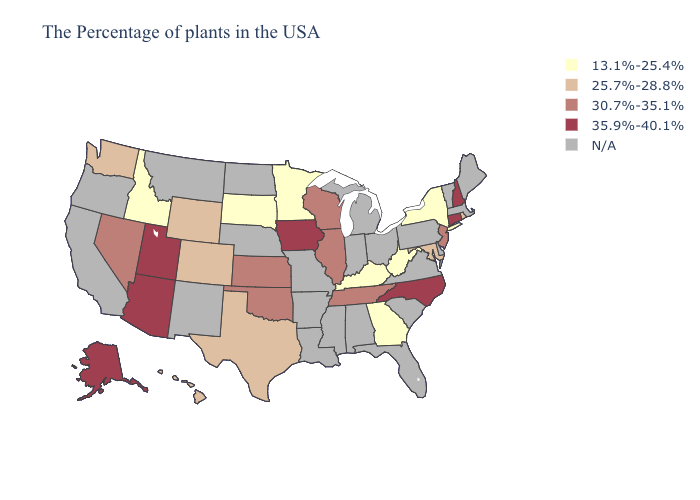Name the states that have a value in the range 30.7%-35.1%?
Short answer required. New Jersey, Tennessee, Wisconsin, Illinois, Kansas, Oklahoma, Nevada. What is the lowest value in the South?
Answer briefly. 13.1%-25.4%. What is the value of West Virginia?
Short answer required. 13.1%-25.4%. What is the value of Kansas?
Quick response, please. 30.7%-35.1%. Which states hav the highest value in the MidWest?
Concise answer only. Iowa. What is the lowest value in the Northeast?
Answer briefly. 13.1%-25.4%. What is the lowest value in the West?
Give a very brief answer. 13.1%-25.4%. What is the highest value in states that border Texas?
Quick response, please. 30.7%-35.1%. Name the states that have a value in the range 30.7%-35.1%?
Quick response, please. New Jersey, Tennessee, Wisconsin, Illinois, Kansas, Oklahoma, Nevada. Name the states that have a value in the range N/A?
Short answer required. Maine, Massachusetts, Vermont, Delaware, Pennsylvania, Virginia, South Carolina, Ohio, Florida, Michigan, Indiana, Alabama, Mississippi, Louisiana, Missouri, Arkansas, Nebraska, North Dakota, New Mexico, Montana, California, Oregon. Does the map have missing data?
Write a very short answer. Yes. Name the states that have a value in the range 25.7%-28.8%?
Answer briefly. Rhode Island, Maryland, Texas, Wyoming, Colorado, Washington, Hawaii. Which states hav the highest value in the South?
Be succinct. North Carolina. What is the value of Kentucky?
Concise answer only. 13.1%-25.4%. 